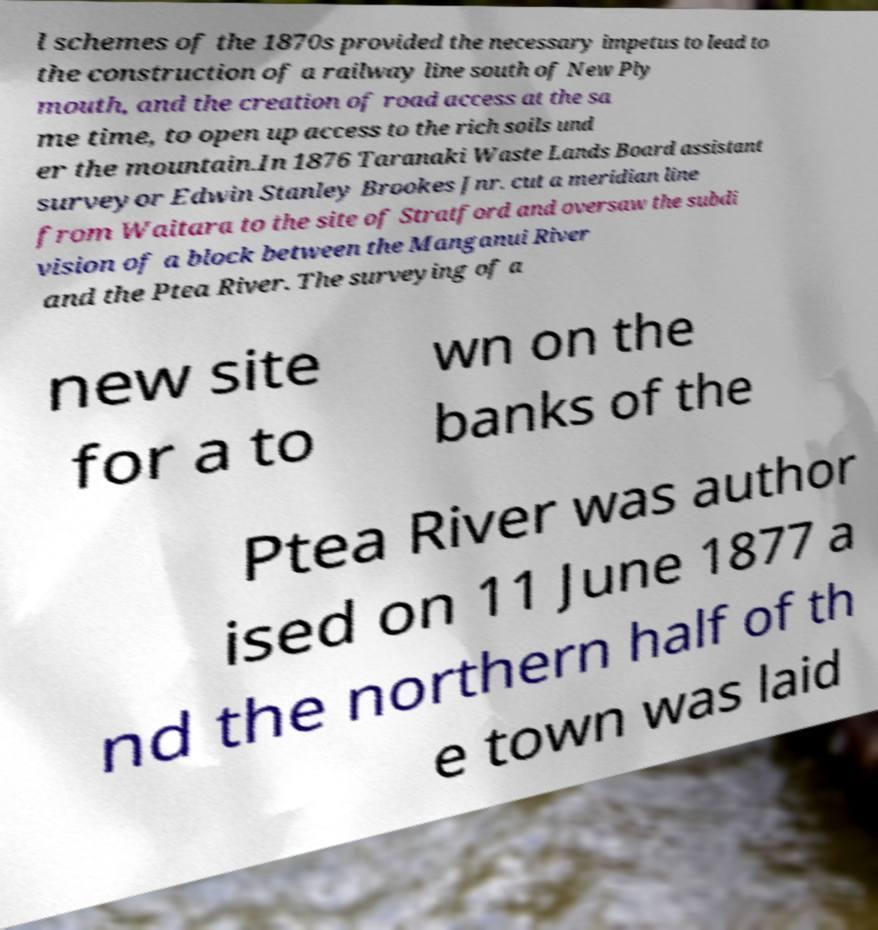I need the written content from this picture converted into text. Can you do that? l schemes of the 1870s provided the necessary impetus to lead to the construction of a railway line south of New Ply mouth, and the creation of road access at the sa me time, to open up access to the rich soils und er the mountain.In 1876 Taranaki Waste Lands Board assistant surveyor Edwin Stanley Brookes Jnr. cut a meridian line from Waitara to the site of Stratford and oversaw the subdi vision of a block between the Manganui River and the Ptea River. The surveying of a new site for a to wn on the banks of the Ptea River was author ised on 11 June 1877 a nd the northern half of th e town was laid 